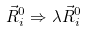<formula> <loc_0><loc_0><loc_500><loc_500>\vec { R } _ { i } ^ { 0 } \Rightarrow \lambda \vec { R } _ { i } ^ { 0 }</formula> 